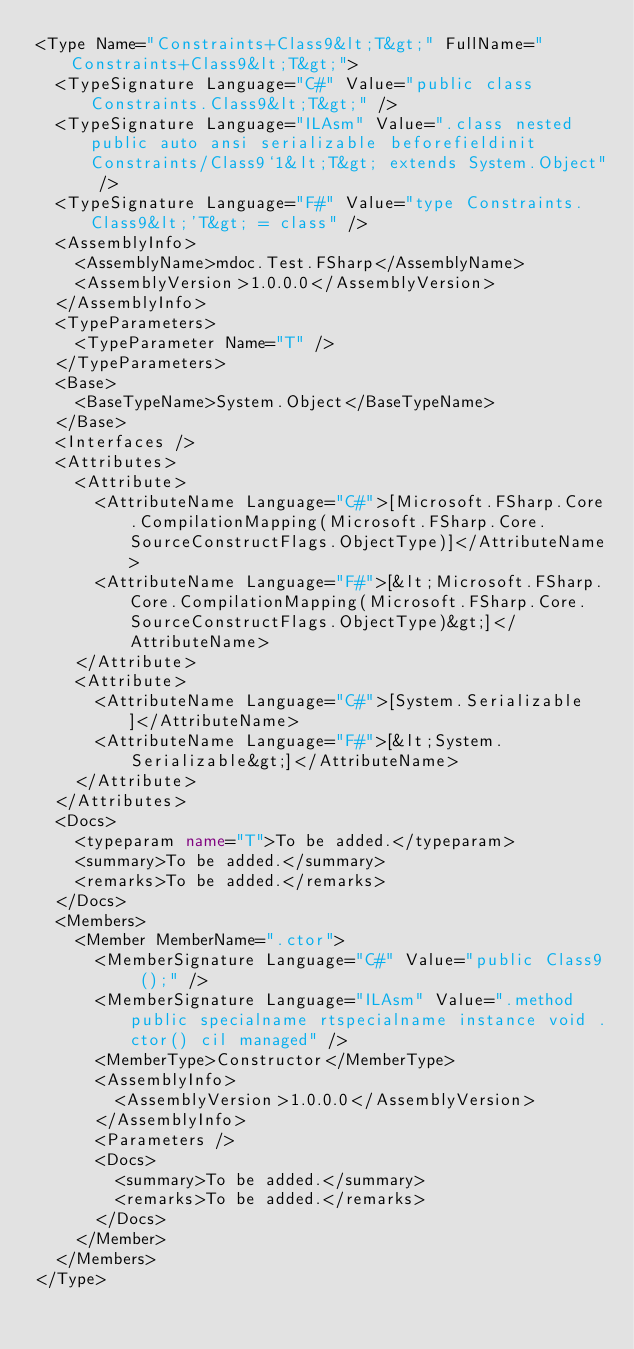<code> <loc_0><loc_0><loc_500><loc_500><_XML_><Type Name="Constraints+Class9&lt;T&gt;" FullName="Constraints+Class9&lt;T&gt;">
  <TypeSignature Language="C#" Value="public class Constraints.Class9&lt;T&gt;" />
  <TypeSignature Language="ILAsm" Value=".class nested public auto ansi serializable beforefieldinit Constraints/Class9`1&lt;T&gt; extends System.Object" />
  <TypeSignature Language="F#" Value="type Constraints.Class9&lt;'T&gt; = class" />
  <AssemblyInfo>
    <AssemblyName>mdoc.Test.FSharp</AssemblyName>
    <AssemblyVersion>1.0.0.0</AssemblyVersion>
  </AssemblyInfo>
  <TypeParameters>
    <TypeParameter Name="T" />
  </TypeParameters>
  <Base>
    <BaseTypeName>System.Object</BaseTypeName>
  </Base>
  <Interfaces />
  <Attributes>
    <Attribute>
      <AttributeName Language="C#">[Microsoft.FSharp.Core.CompilationMapping(Microsoft.FSharp.Core.SourceConstructFlags.ObjectType)]</AttributeName>
      <AttributeName Language="F#">[&lt;Microsoft.FSharp.Core.CompilationMapping(Microsoft.FSharp.Core.SourceConstructFlags.ObjectType)&gt;]</AttributeName>
    </Attribute>
    <Attribute>
      <AttributeName Language="C#">[System.Serializable]</AttributeName>
      <AttributeName Language="F#">[&lt;System.Serializable&gt;]</AttributeName>
    </Attribute>
  </Attributes>
  <Docs>
    <typeparam name="T">To be added.</typeparam>
    <summary>To be added.</summary>
    <remarks>To be added.</remarks>
  </Docs>
  <Members>
    <Member MemberName=".ctor">
      <MemberSignature Language="C#" Value="public Class9 ();" />
      <MemberSignature Language="ILAsm" Value=".method public specialname rtspecialname instance void .ctor() cil managed" />
      <MemberType>Constructor</MemberType>
      <AssemblyInfo>
        <AssemblyVersion>1.0.0.0</AssemblyVersion>
      </AssemblyInfo>
      <Parameters />
      <Docs>
        <summary>To be added.</summary>
        <remarks>To be added.</remarks>
      </Docs>
    </Member>
  </Members>
</Type>
</code> 